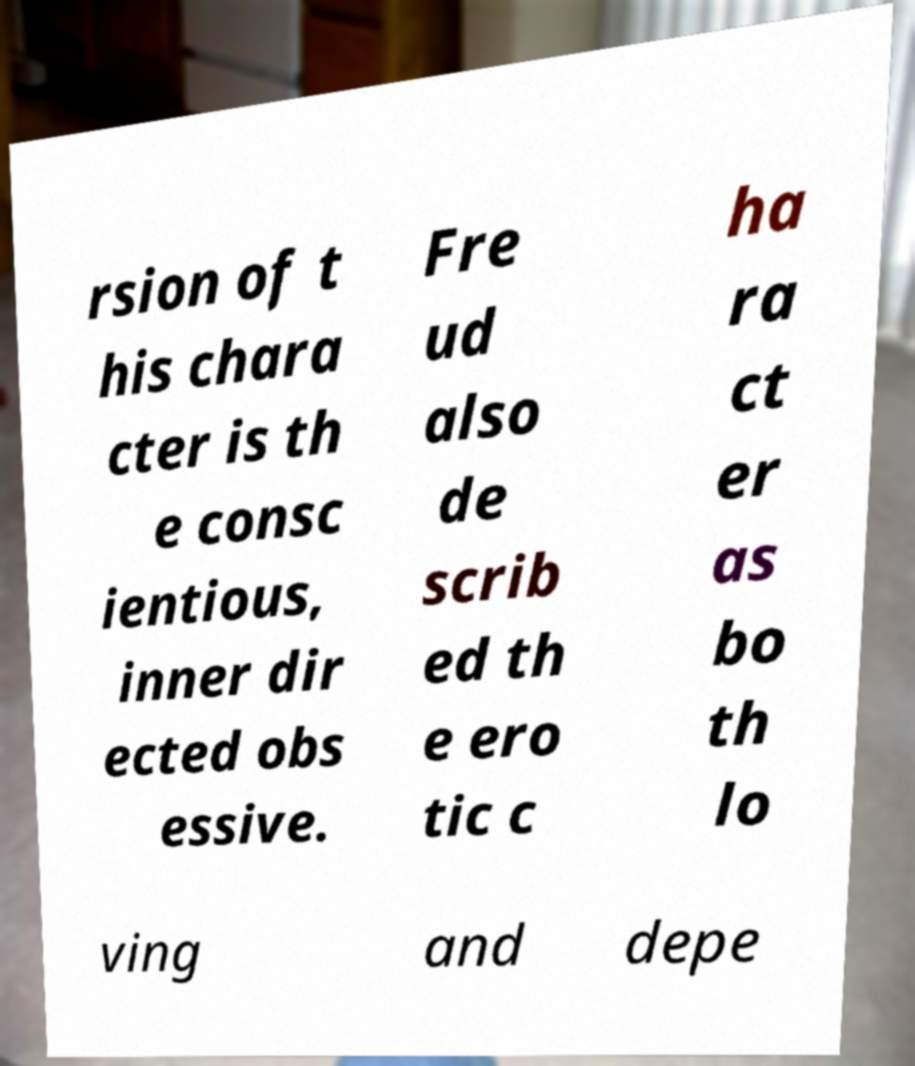Can you read and provide the text displayed in the image?This photo seems to have some interesting text. Can you extract and type it out for me? rsion of t his chara cter is th e consc ientious, inner dir ected obs essive. Fre ud also de scrib ed th e ero tic c ha ra ct er as bo th lo ving and depe 